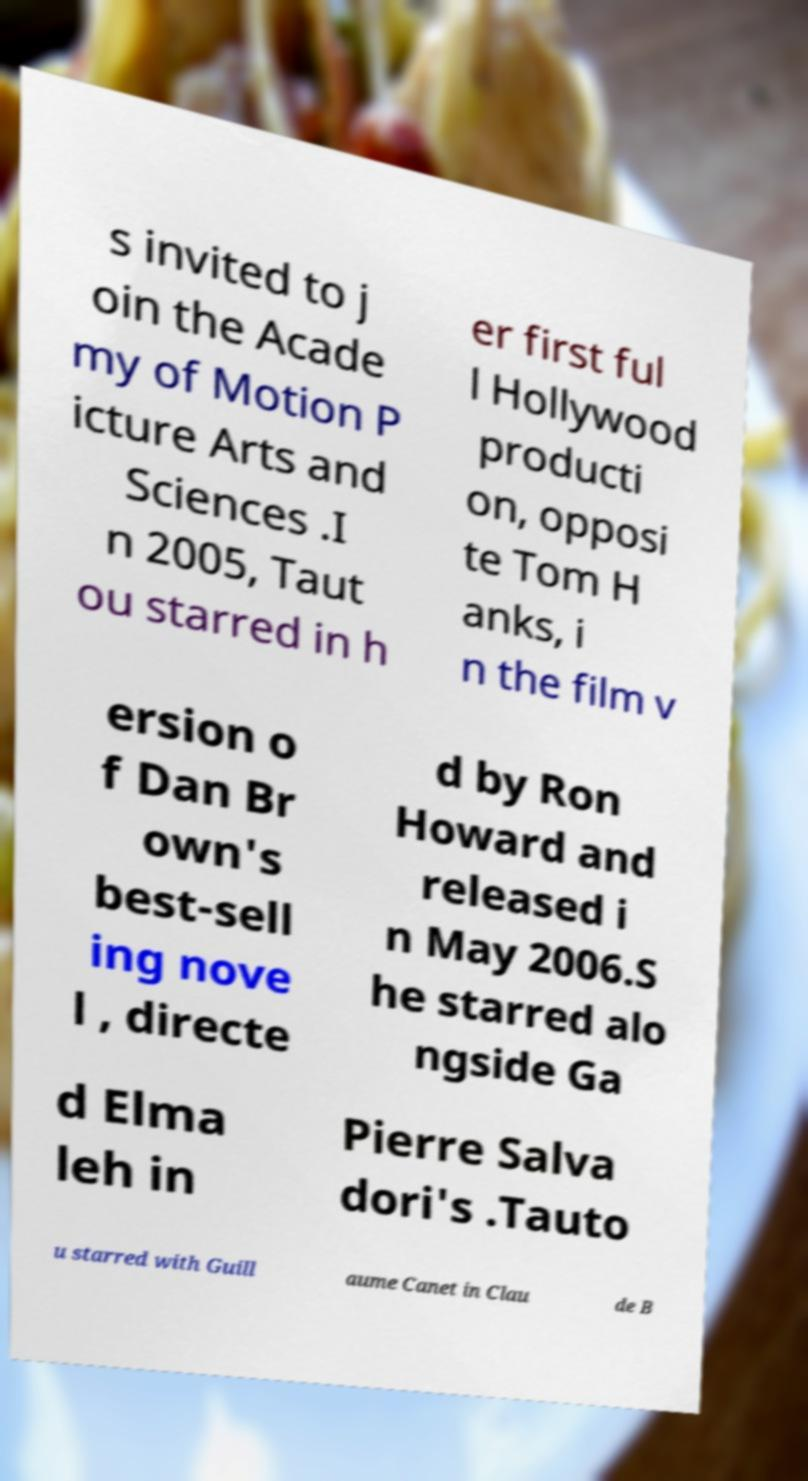I need the written content from this picture converted into text. Can you do that? s invited to j oin the Acade my of Motion P icture Arts and Sciences .I n 2005, Taut ou starred in h er first ful l Hollywood producti on, opposi te Tom H anks, i n the film v ersion o f Dan Br own's best-sell ing nove l , directe d by Ron Howard and released i n May 2006.S he starred alo ngside Ga d Elma leh in Pierre Salva dori's .Tauto u starred with Guill aume Canet in Clau de B 